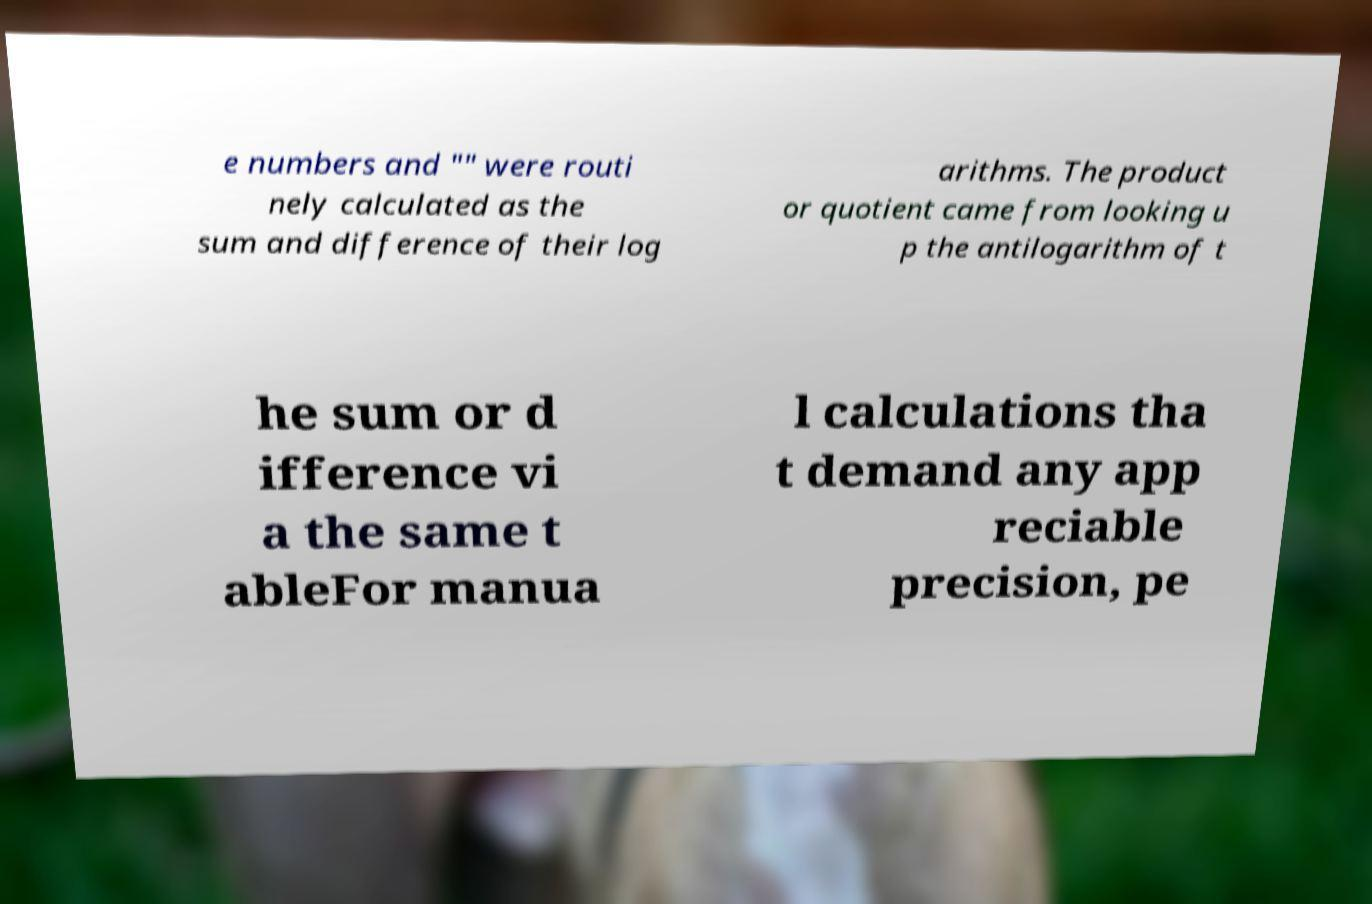Could you assist in decoding the text presented in this image and type it out clearly? e numbers and "" were routi nely calculated as the sum and difference of their log arithms. The product or quotient came from looking u p the antilogarithm of t he sum or d ifference vi a the same t ableFor manua l calculations tha t demand any app reciable precision, pe 